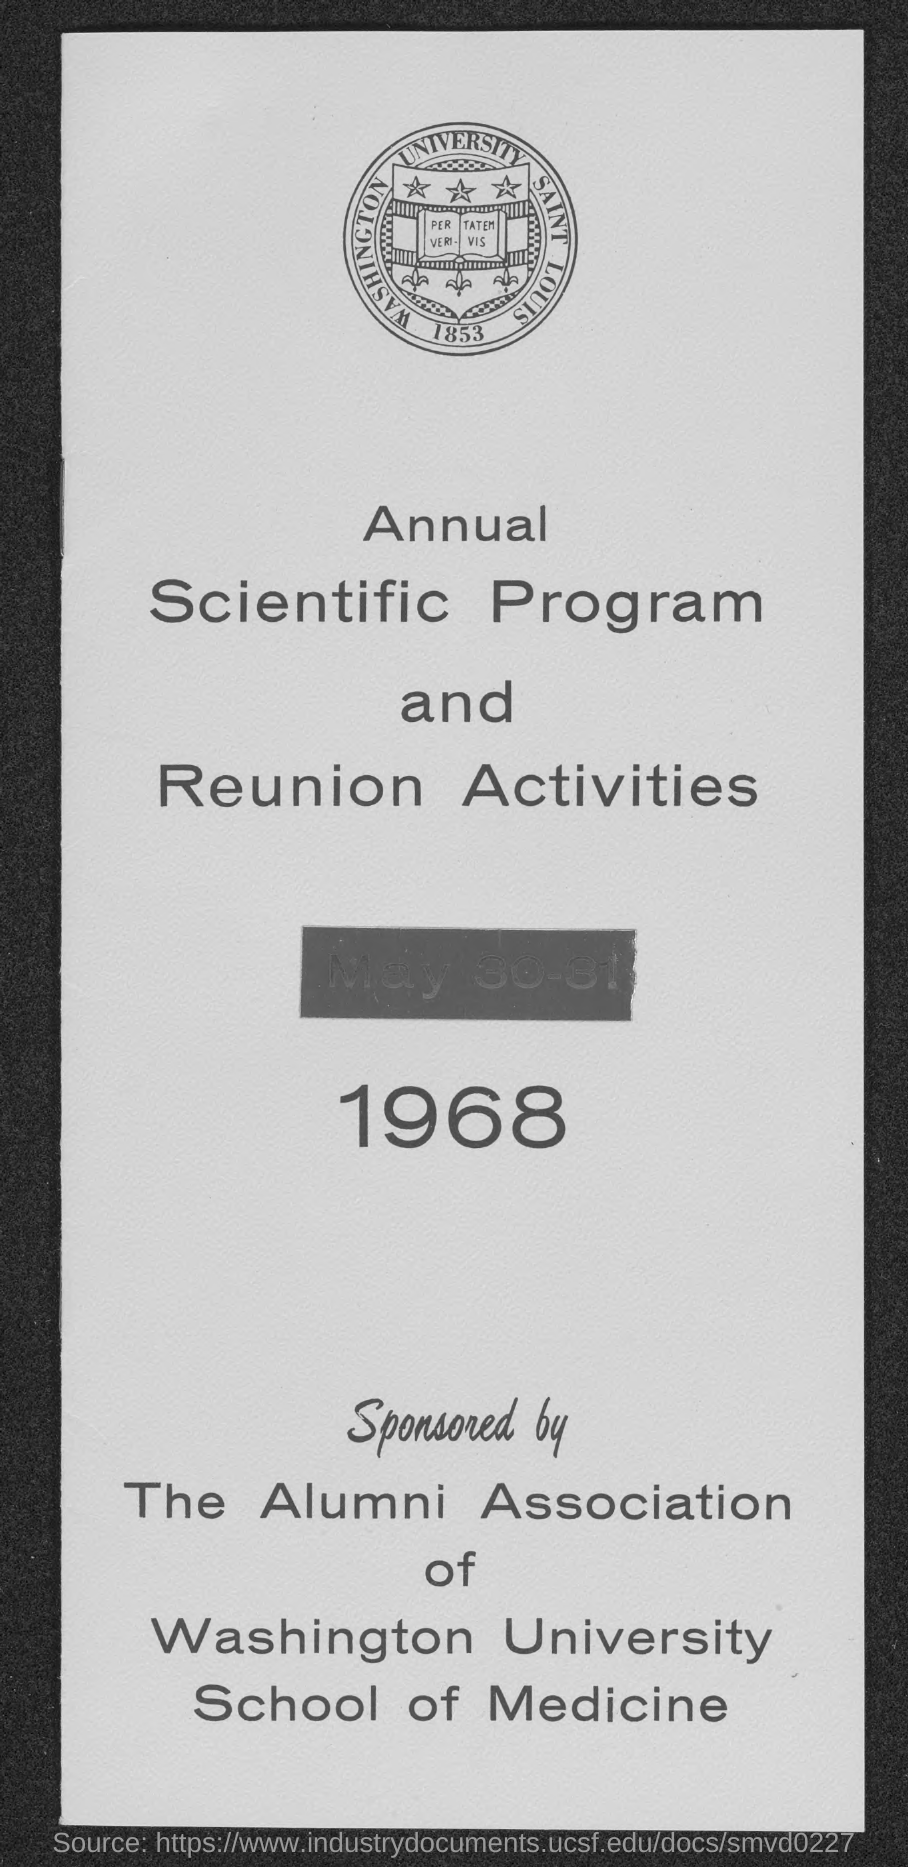What is the date on the document?
Make the answer very short. MAY 30-31 1968. 